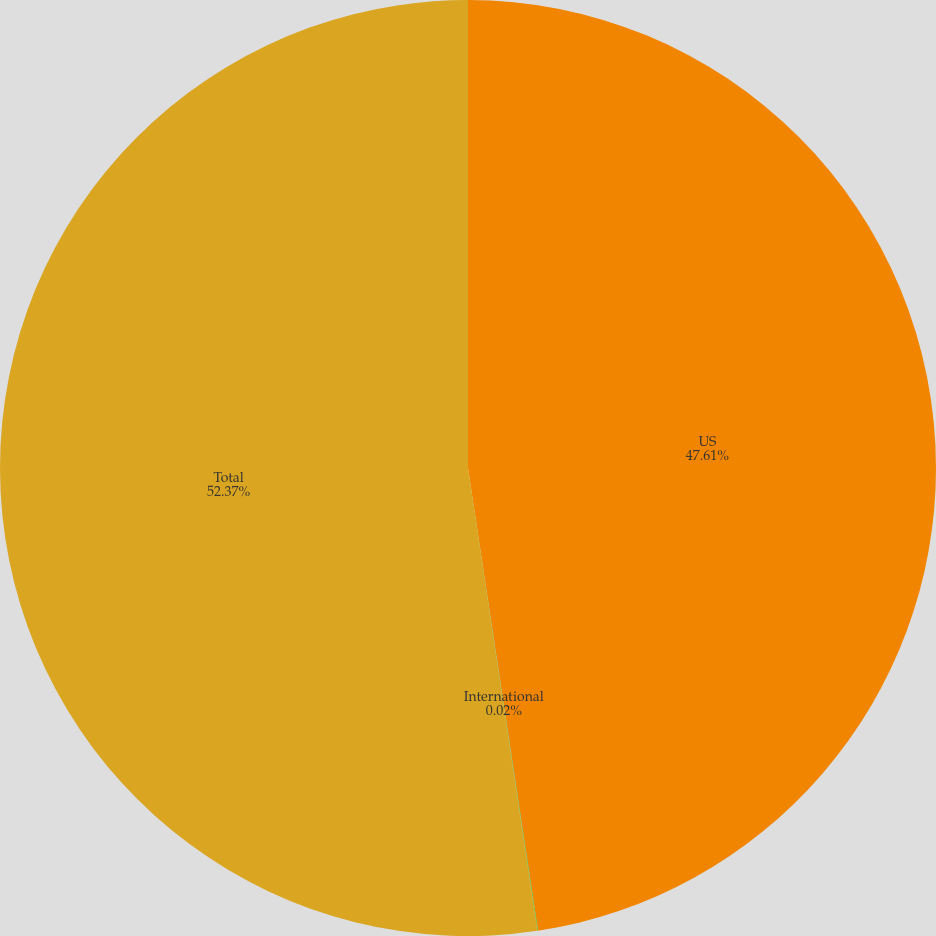Convert chart. <chart><loc_0><loc_0><loc_500><loc_500><pie_chart><fcel>US<fcel>International<fcel>Total<nl><fcel>47.61%<fcel>0.02%<fcel>52.37%<nl></chart> 